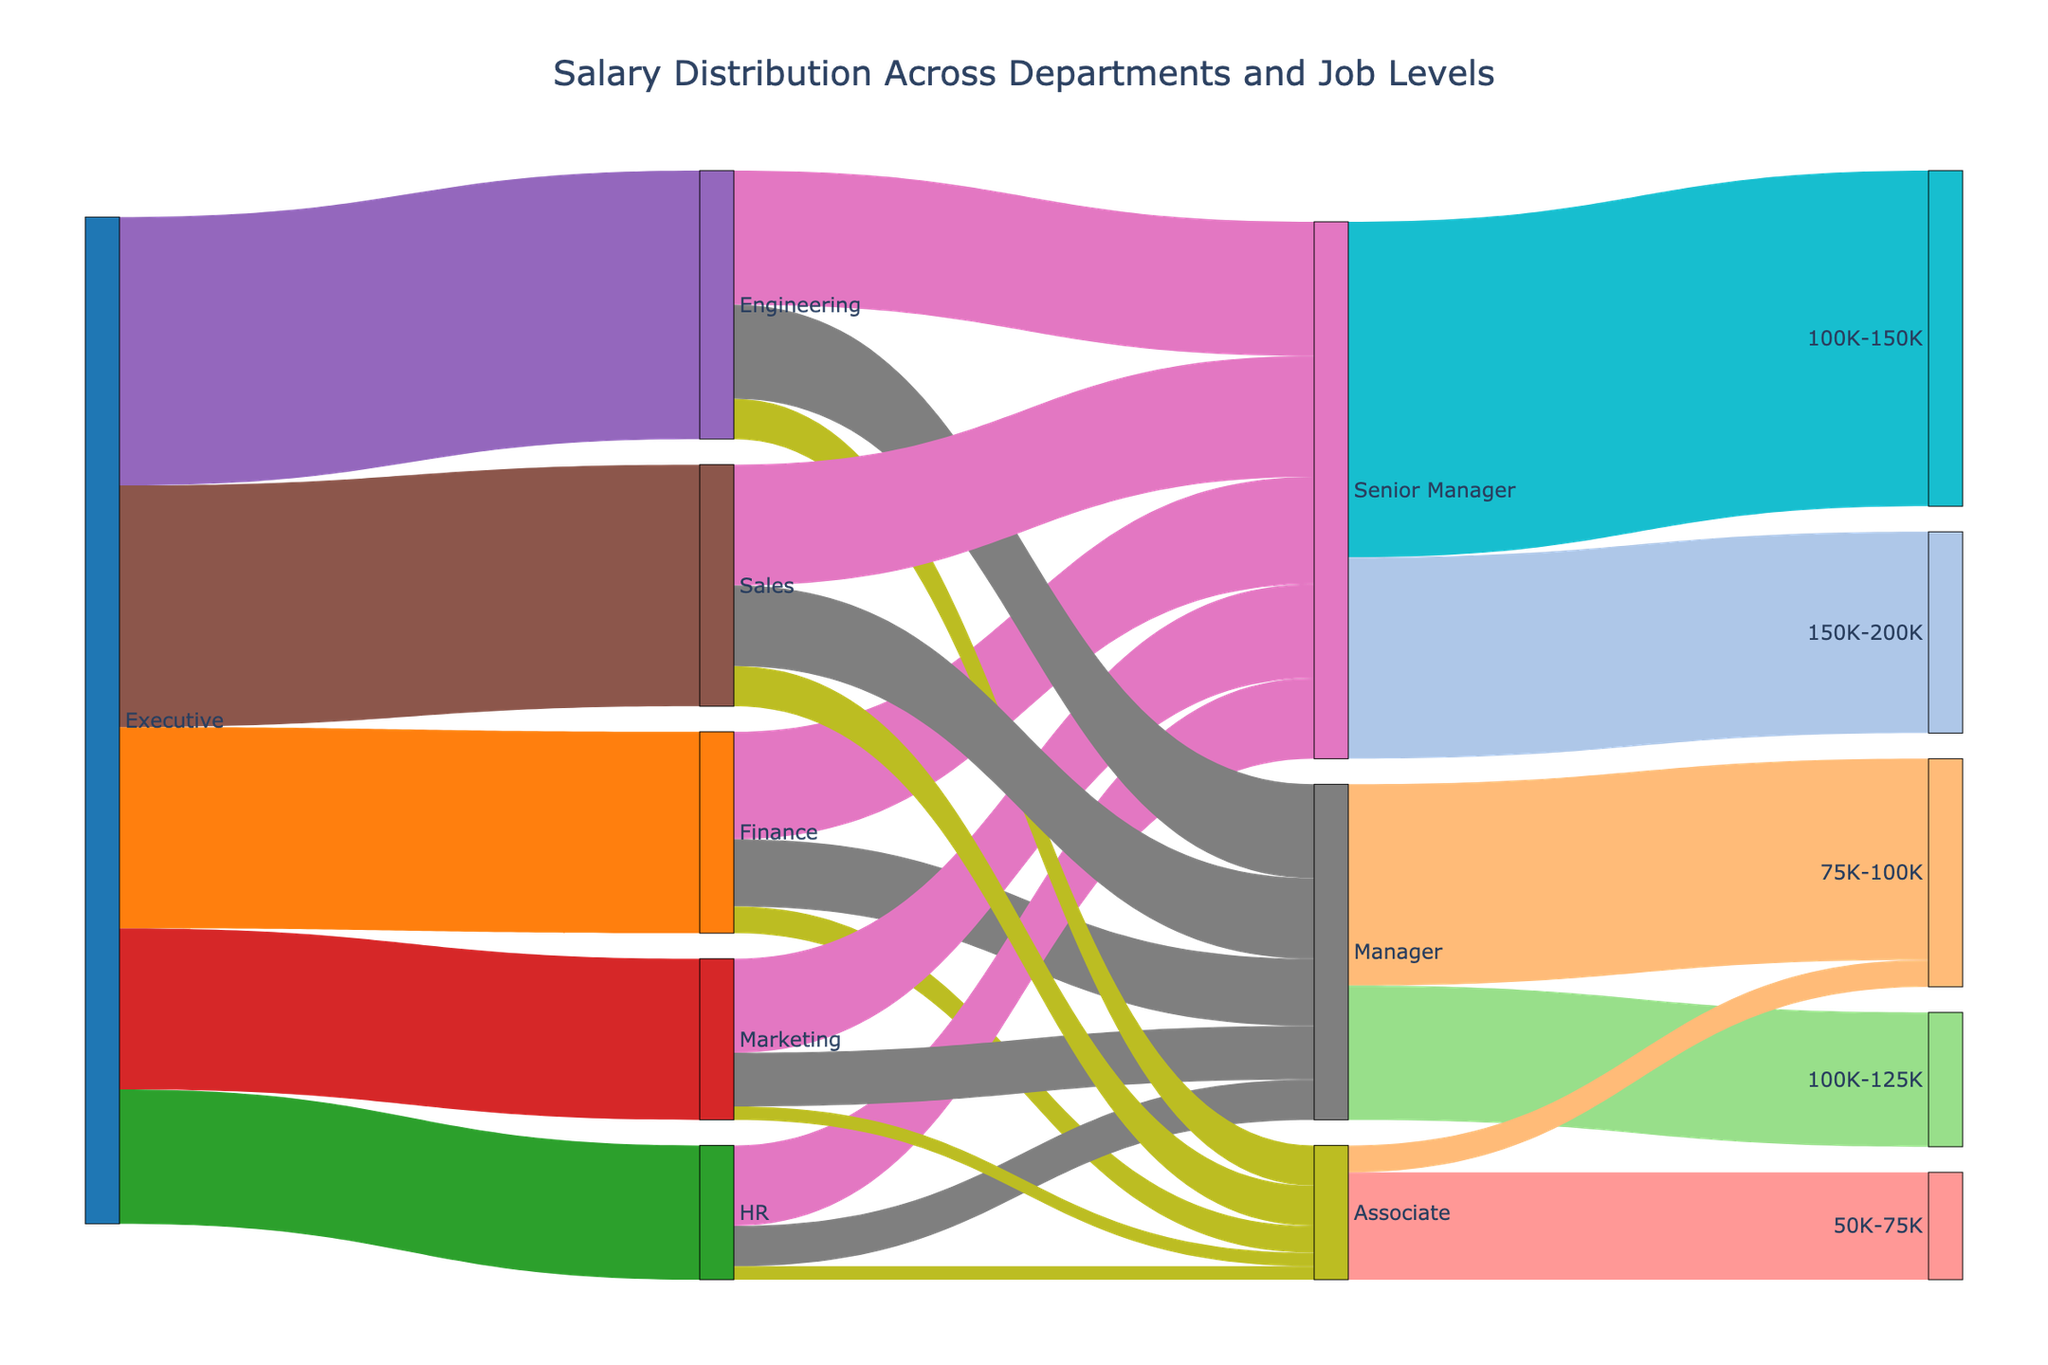What is the overall title of the diagram? The title is displayed at the top of the figure and provides an overarching description of the content. The text reads "Salary Distribution Across Departments and Job Levels".
Answer: Salary Distribution Across Departments and Job Levels How many job levels are represented in the diagram? The job levels are listed on the left side of the diagram under different departments and include 'Senior Manager', 'Manager', and 'Associate'. Count these distinct job levels.
Answer: 3 Which department has the highest salary allocation for the 'Senior Manager' job level? Trace the links from the 'Senior Manager' label to the respective departments and compare the 'value'. Engineering has the highest value with 100.
Answer: Engineering What is the total salary allocation for the 'Finance' department? Sum the values for all flows originating from the 'Finance' department: 80 (Senior Manager) + 50 (Manager) + 20 (Associate). 80 + 50 + 20 = 150.
Answer: 150 How does the salary distribution for 'Managers' compare between 'Sales' and 'Marketing'? Compare the values of the links from 'Sales' and 'Marketing' to 'Manager'. Sales has 60 and Marketing has 40. Sales is greater.
Answer: Sales has a higher salary distribution for Managers Which salary range has the highest number of 'Senior Managers'? Trace the links leaving 'Senior Manager' and check the values associated with the salary ranges. The 100K-150K range has a value of 250.
Answer: 100K-150K What proportion of the total salary allocated to 'Associates' falls within the 50K-75K salary range? Sum the values for all 'Associate' salary ranges (50K-75K and 75K-100K), then divide the value for the 50K-75K range by this sum: (80 / (80+20)) = 80/100 = 0.8 (which is 80%).
Answer: 80% Which department contributes the most towards the 150K-200K salary range? Trace the links to the 150K-200K salary range and identify the contributing job levels and their departments. The largest contribution comes from the 'Senior Manager' level, with 150, with the largest share coming from 'Engineering'.
Answer: Engineering How many links are there in total in the diagram? Count all the lines (links) connecting the various nodes, i.e., 22 links from Executives to Departments, 20 links from Departments to Job Levels, and 6 links from Job Levels to Salary Ranges. Therefore, the total is 22 + 20 + 6 = 48.
Answer: 48 Which department shows the smallest salary allocation for 'Managers'? Check the values of all links from each department to 'Manager'. HR has the smallest value of 30.
Answer: HR 